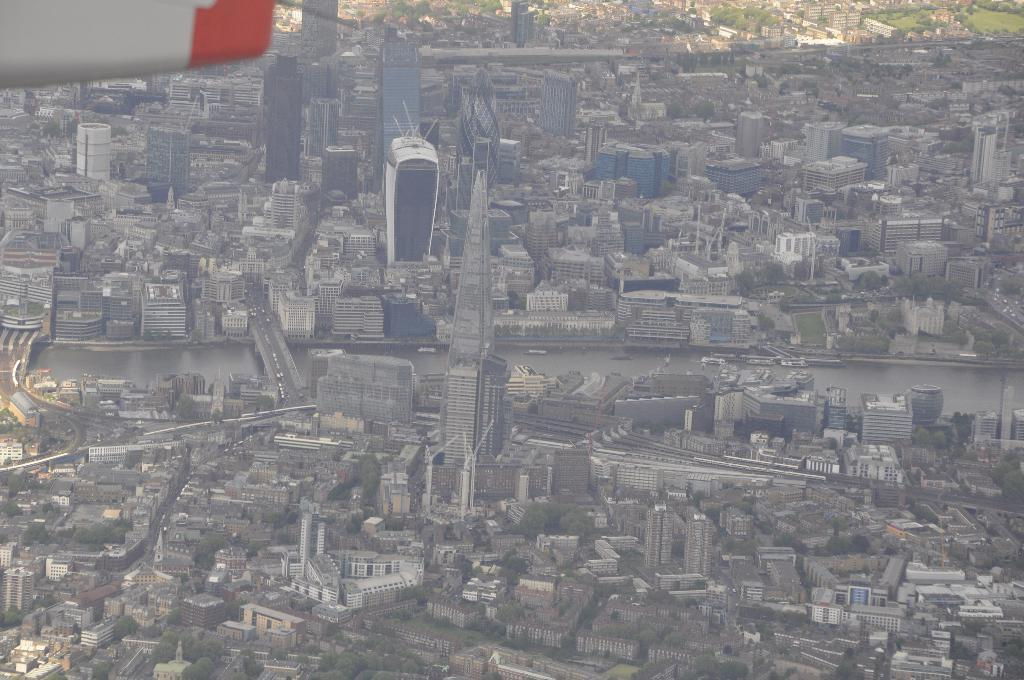What is the perspective of the image? The image provides a view from a height. What can be seen from this elevated perspective? There are many buildings visible on the ground. What type of faucet can be seen in the image? There is no faucet present in the image. What is the effect of the pollution on the buildings in the image? There is no mention of pollution in the image, so it is not possible to determine its effect on the buildings. 